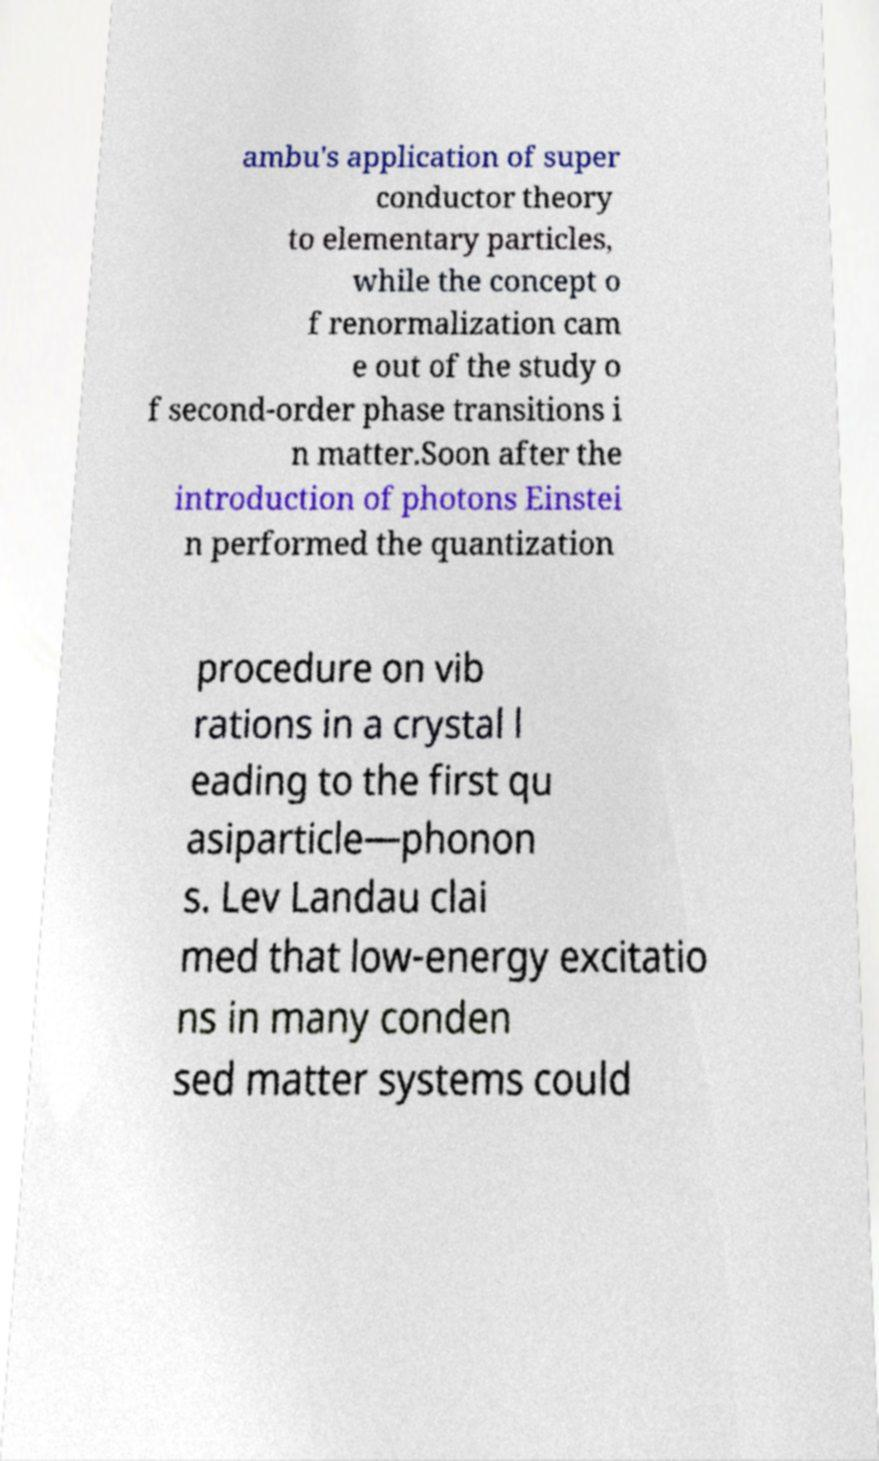For documentation purposes, I need the text within this image transcribed. Could you provide that? ambu's application of super conductor theory to elementary particles, while the concept o f renormalization cam e out of the study o f second-order phase transitions i n matter.Soon after the introduction of photons Einstei n performed the quantization procedure on vib rations in a crystal l eading to the first qu asiparticle—phonon s. Lev Landau clai med that low-energy excitatio ns in many conden sed matter systems could 